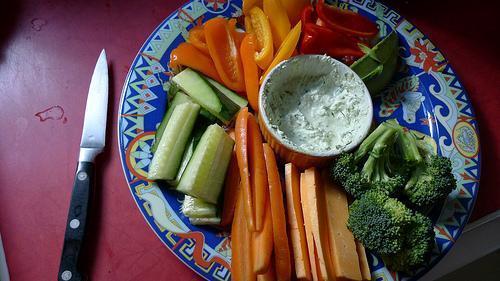How many cups of dip are in photo?
Give a very brief answer. 1. 